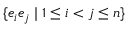<formula> <loc_0><loc_0><loc_500><loc_500>\{ e _ { i } e _ { j } | 1 \leq i < j \leq n \}</formula> 